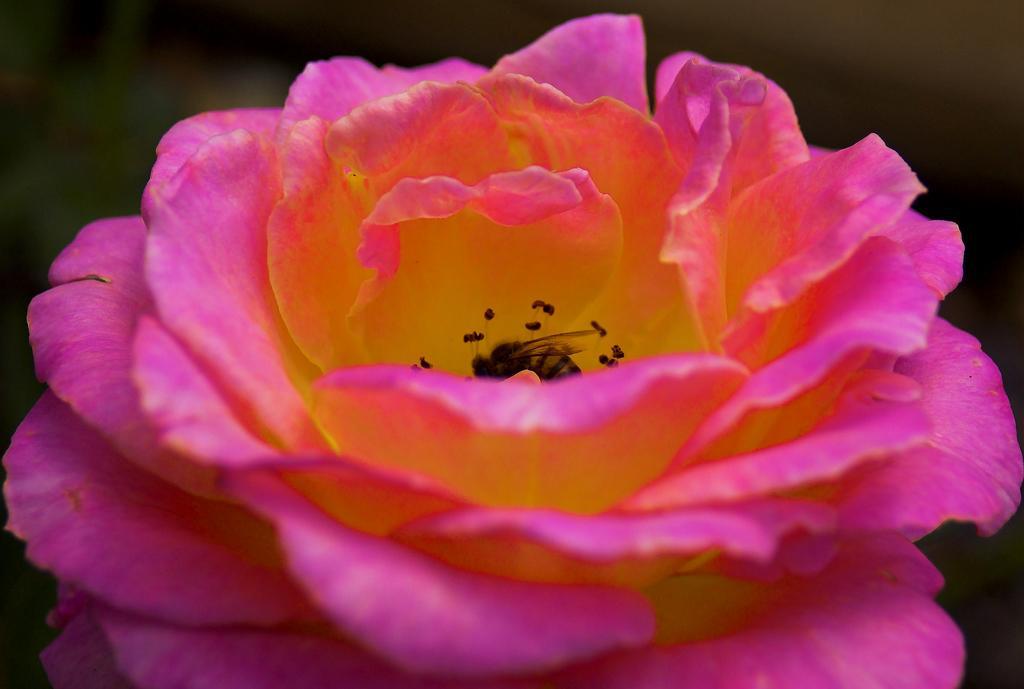Describe this image in one or two sentences. Here in this picture we can see a flower present and in the middle of it we can see pollen grains with a bee present on it. 